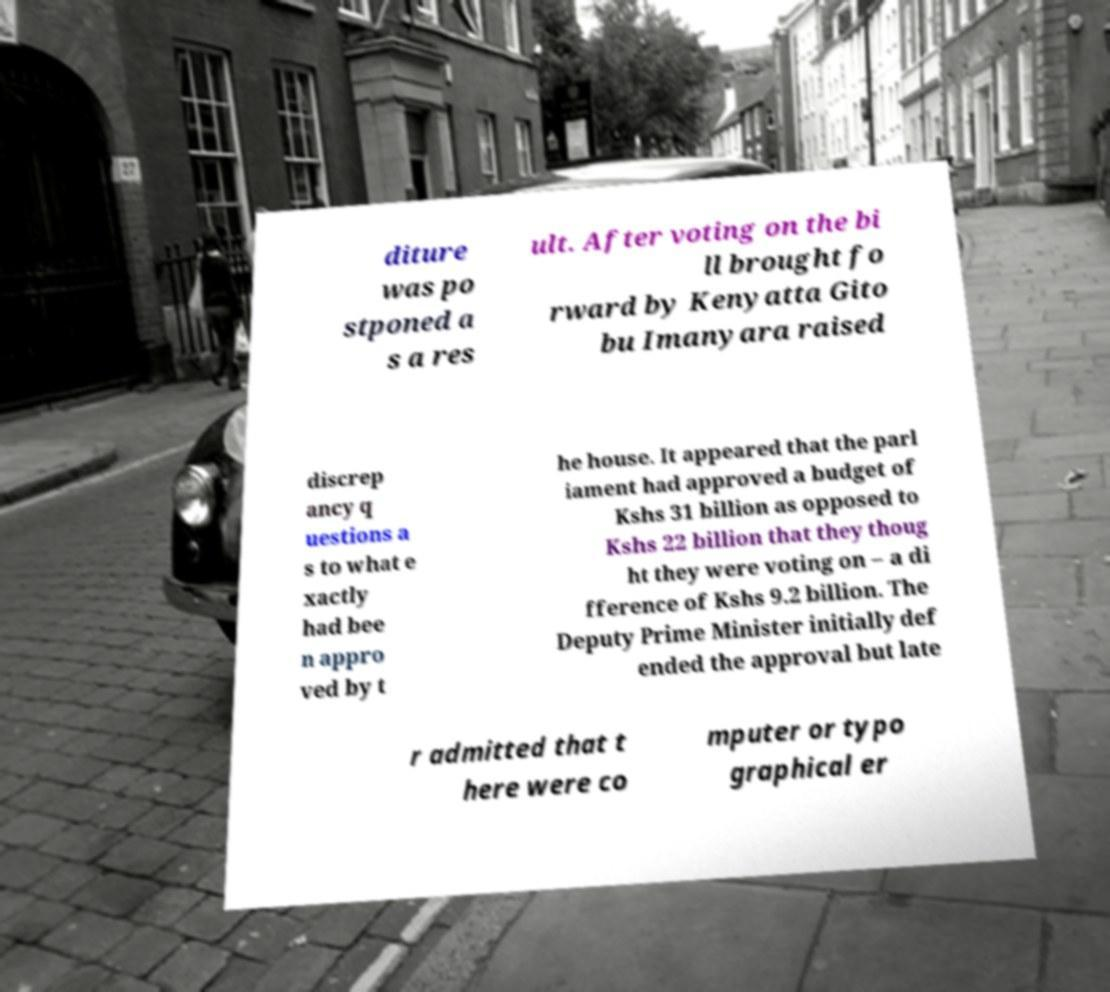Please read and relay the text visible in this image. What does it say? diture was po stponed a s a res ult. After voting on the bi ll brought fo rward by Kenyatta Gito bu Imanyara raised discrep ancy q uestions a s to what e xactly had bee n appro ved by t he house. It appeared that the parl iament had approved a budget of Kshs 31 billion as opposed to Kshs 22 billion that they thoug ht they were voting on – a di fference of Kshs 9.2 billion. The Deputy Prime Minister initially def ended the approval but late r admitted that t here were co mputer or typo graphical er 